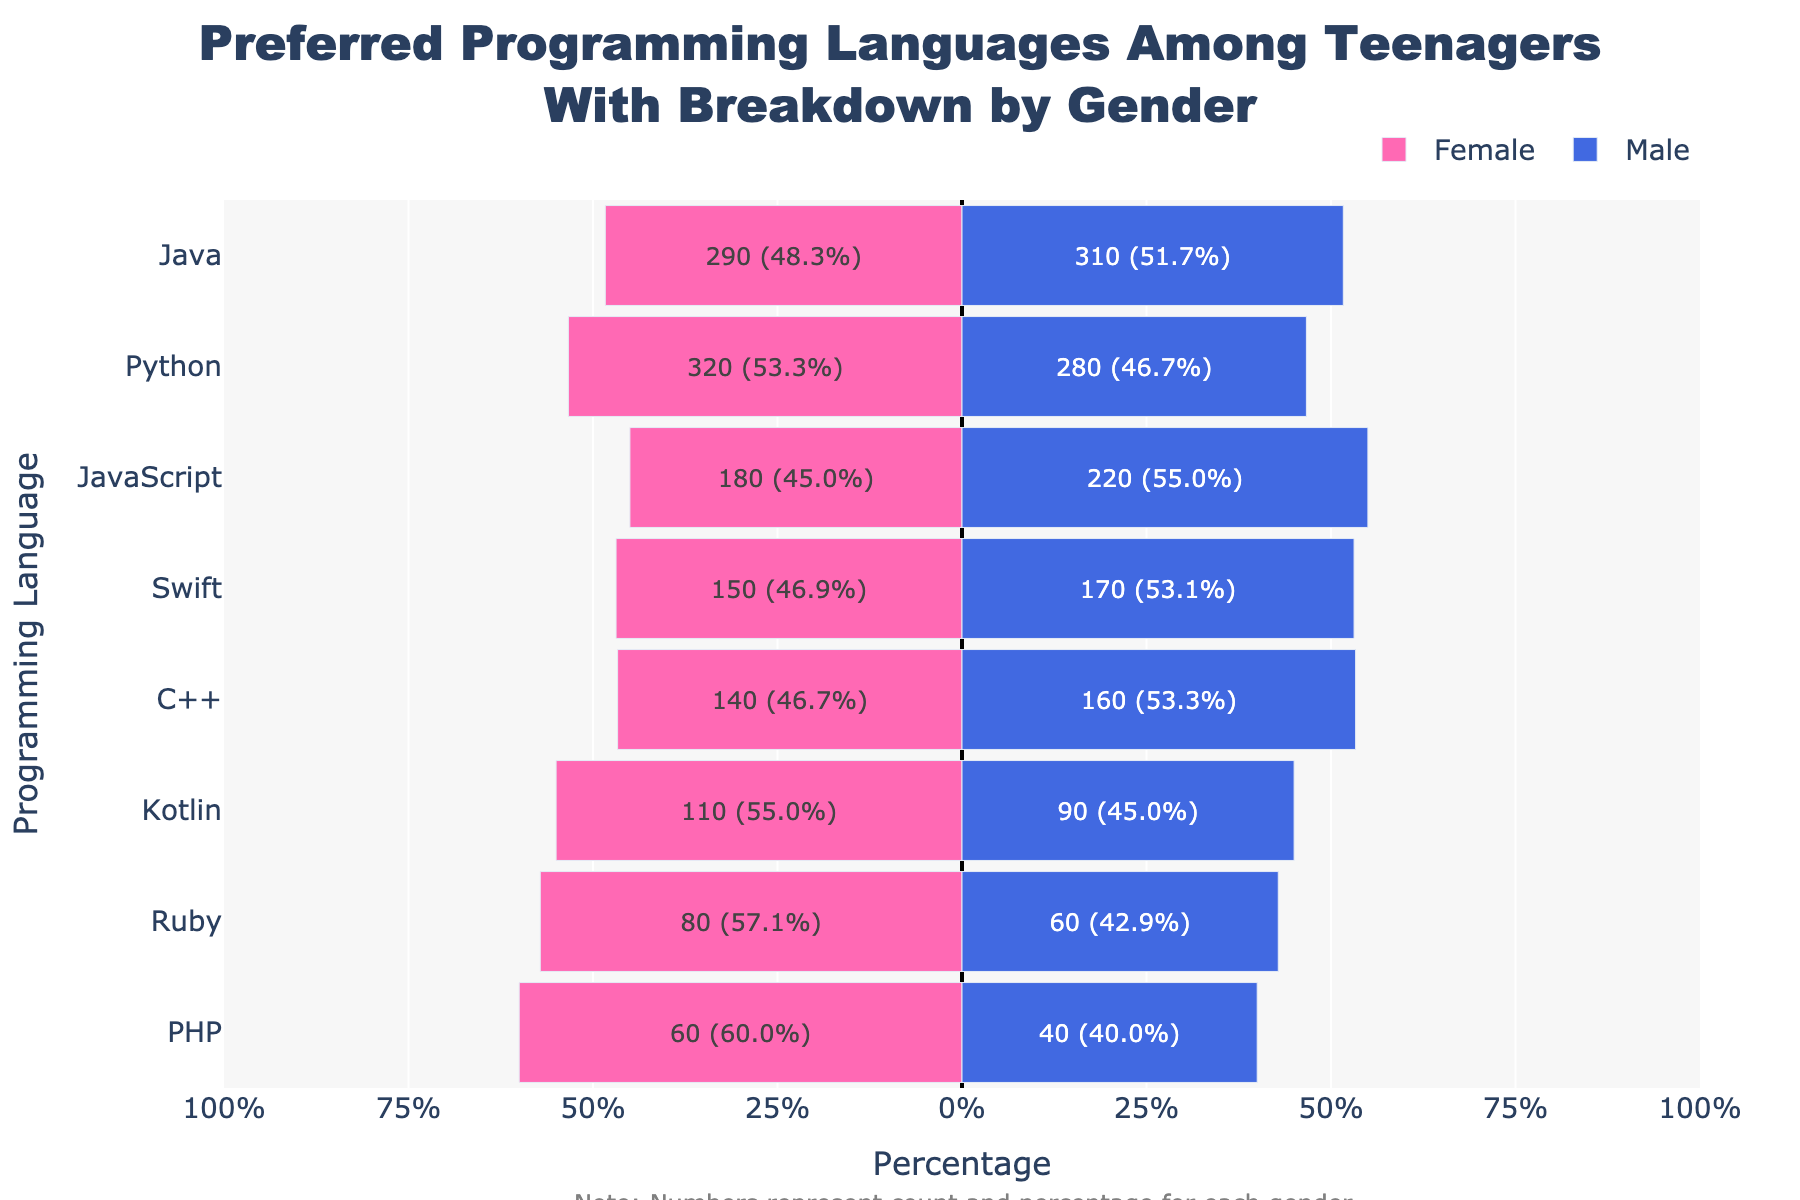Which programming language is the most preferred among teenagers? The programming language with the highest overall count is Python, with 320 females and 280 males, summing up to 600.
Answer: Python Which gender prefers JavaScript more? The figure shows that the percentage bar for males (220 or 55%) extends further for JavaScript than for females (180 or 45%).
Answer: Male What's the sum of teenagers who prefer Ruby? Adding the count of females and males for Ruby gives us 80 + 60 = 140.
Answer: 140 Identify the programming language with the smallest gender gap and state the gap. The language with the smallest gap can be found by comparing the absolute difference in percentage for each language. For Java, females are 48.3% and males are 51.7%, so the gap is 3.4%.
Answer: Java, 3.4% What percentage of teenagers who prefer C++ are female, and how does this compare to the percentage for Kotlin? The percentage for females who prefer C++ is 46.7%, calculated as (140 / (140 + 160) * 100). For Kotlin, it's 55%, calculated as (110 / (110 + 90) * 100). The comparison shows that a higher percentage of females prefer Kotlin over C++.
Answer: C++: 46.7%, Kotlin: 55% Which programming language has the largest percentage of female preference? By checking the female percentage in each category, Python has the highest female percentage at 53.33%.
Answer: Python Which languages do 170 teenagers prefer, and what are the gender counts? Checking the total counts, Swift is preferred by 170 teenagers (150 females and 170 males).
Answer: Swift, Female: 150, Male: 170 Compare the visual lengths of the bars representing Kotlin preferences for males and females. The bars for males and females for Kotlin show the percentage distribution. The male bar is 45% and the female bar is 55%, visually showing the female bar being slightly longer.
Answer: Female bar is longer What's the sum of teenagers who prefer Python and Java? Adding the individual counts: Python (320 females + 280 males) and Java (290 females + 310 males) gives 600 + 600 = 1200.
Answer: 1200 